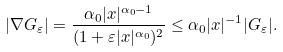<formula> <loc_0><loc_0><loc_500><loc_500>| \nabla G _ { \varepsilon } | = \frac { \alpha _ { 0 } | x | ^ { \alpha _ { 0 } - 1 } } { ( 1 + \varepsilon | x | ^ { \alpha _ { 0 } } ) ^ { 2 } } \leq \alpha _ { 0 } | x | ^ { - 1 } | G _ { \varepsilon } | .</formula> 